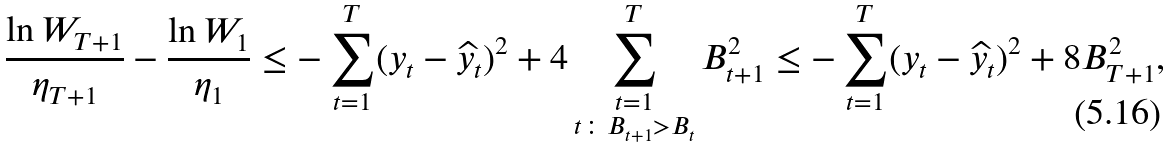Convert formula to latex. <formula><loc_0><loc_0><loc_500><loc_500>\frac { \ln W _ { T + 1 } } { \eta _ { T + 1 } } - \frac { \ln W _ { 1 } } { \eta _ { 1 } } \leq - \sum _ { t = 1 } ^ { T } ( y _ { t } - \widehat { y } _ { t } ) ^ { 2 } + 4 \sum _ { \substack { t = 1 \\ t \colon B _ { t + 1 } > B _ { t } } } ^ { T } B _ { t + 1 } ^ { 2 } \leq - \sum _ { t = 1 } ^ { T } ( y _ { t } - \widehat { y } _ { t } ) ^ { 2 } + 8 B _ { T + 1 } ^ { 2 } ,</formula> 